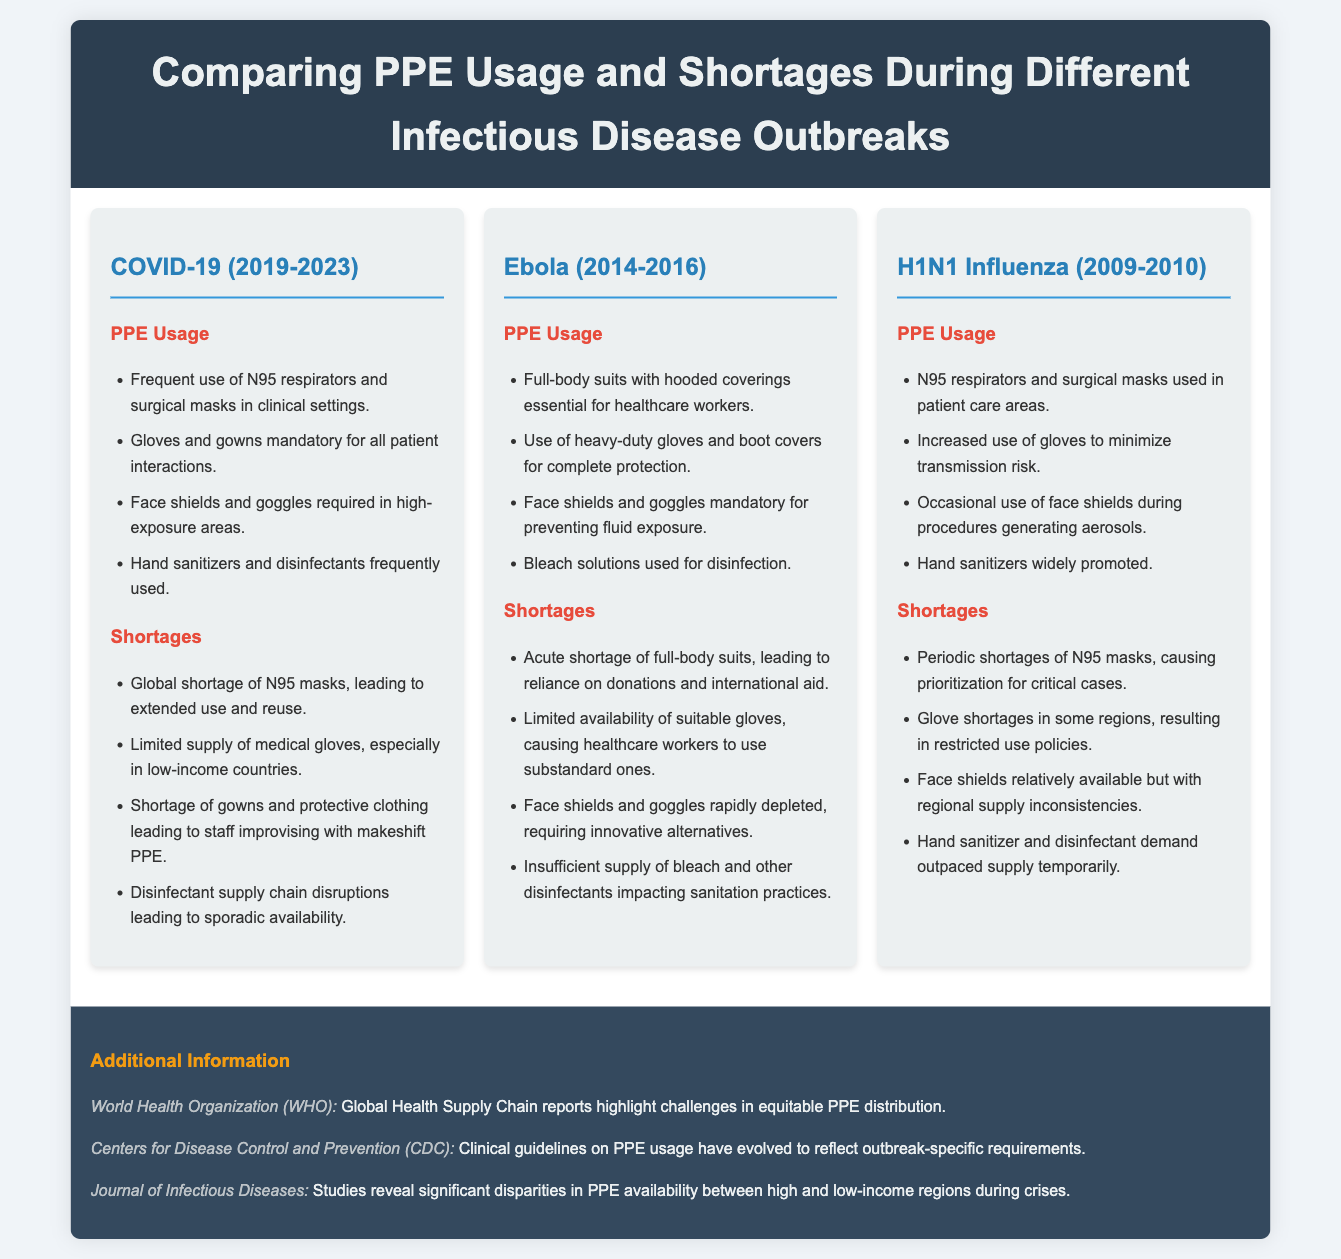what is the primary PPE used in COVID-19? The document lists N95 respirators and surgical masks as the primary PPE in clinical settings during COVID-19.
Answer: N95 respirators and surgical masks what was a significant PPE shortage during the Ebola outbreak? According to the document, there was an acute shortage of full-body suits during the Ebola outbreak.
Answer: Full-body suits how many infectious disease outbreaks are compared in the document? The document compares three infectious disease outbreaks: COVID-19, Ebola, and H1N1 Influenza.
Answer: Three what PPE items were required in high-exposure areas for COVID-19? The document mentions face shields and goggles as required PPE in high-exposure areas during COVID-19.
Answer: Face shields and goggles what was a common disinfectant used during the Ebola outbreak? The document states that bleach solutions were used for disinfection during the Ebola outbreak.
Answer: Bleach solutions which outbreak had a reliance on donations for PPE? The document indicates that the Ebola outbreak involved reliance on donations for PPE, particularly full-body suits.
Answer: Ebola what was a specific issue with glove supply during the H1N1 outbreak? The document notes glove shortages in some regions during the H1N1 outbreak.
Answer: Glove shortages how did the COVID-19 outbreak affect the supply chain for disinfectants? The document explains that disruptions in the disinfectant supply chain led to sporadic availability during COVID-19.
Answer: Supply chain disruptions 